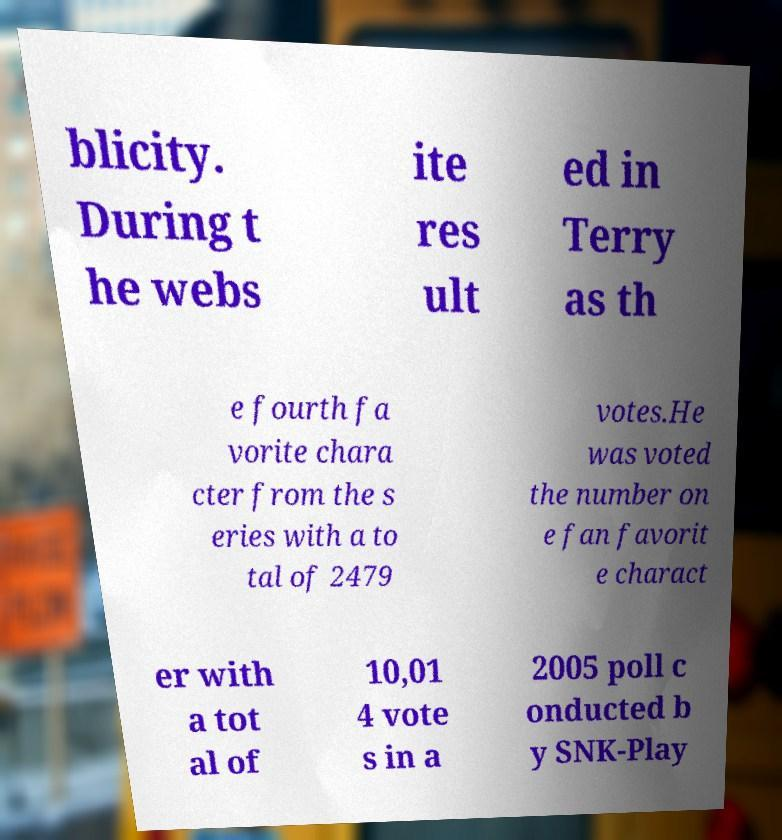Can you accurately transcribe the text from the provided image for me? blicity. During t he webs ite res ult ed in Terry as th e fourth fa vorite chara cter from the s eries with a to tal of 2479 votes.He was voted the number on e fan favorit e charact er with a tot al of 10,01 4 vote s in a 2005 poll c onducted b y SNK-Play 